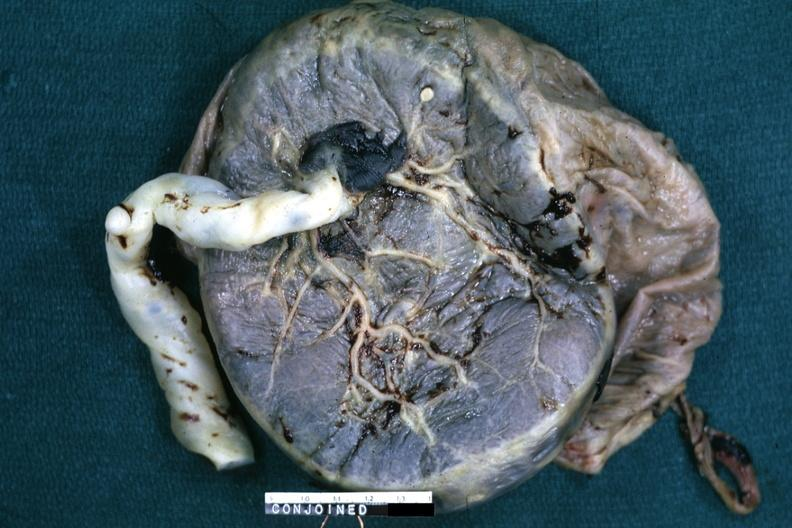what is present?
Answer the question using a single word or phrase. Female reproductive 